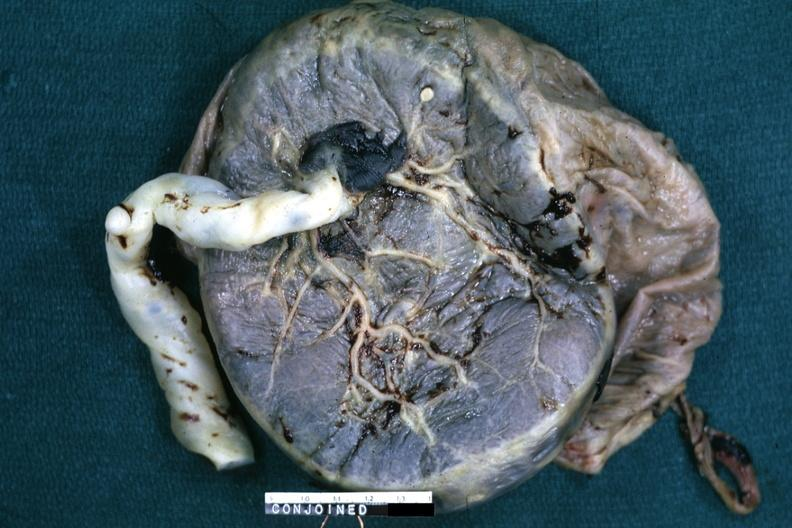what is present?
Answer the question using a single word or phrase. Female reproductive 